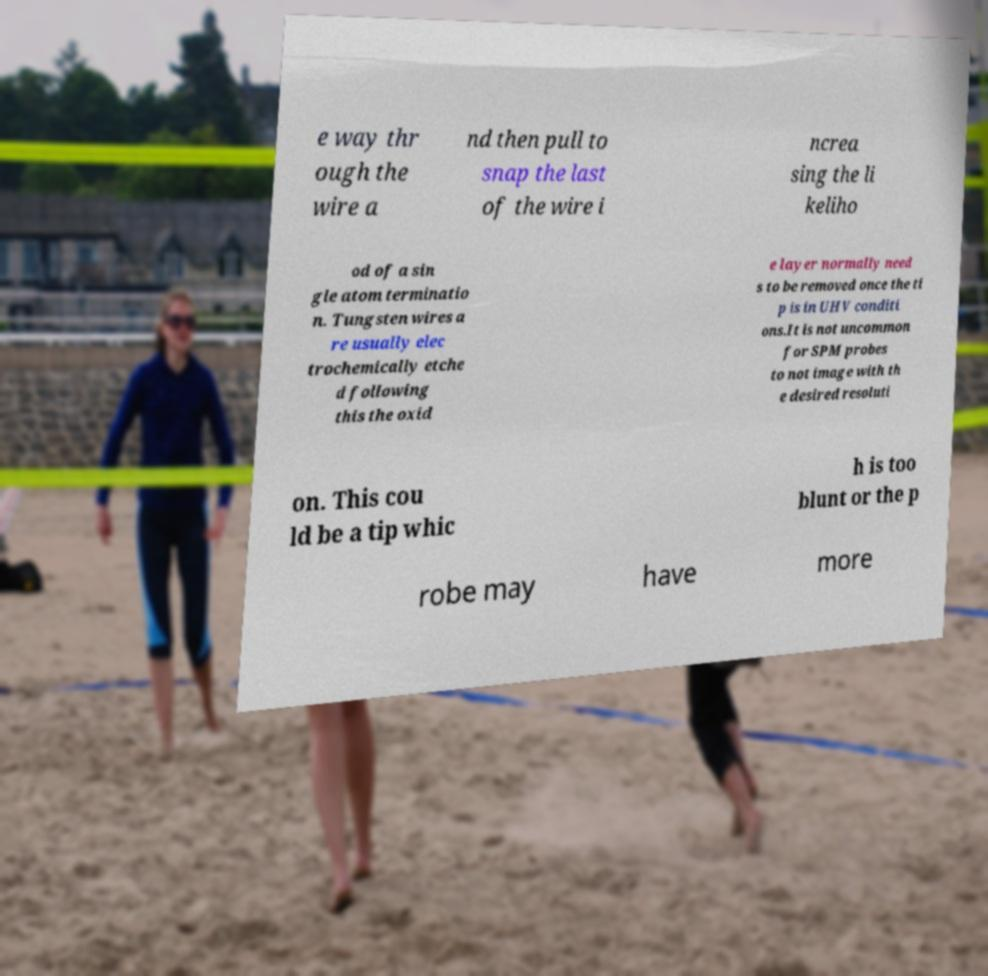Could you extract and type out the text from this image? e way thr ough the wire a nd then pull to snap the last of the wire i ncrea sing the li keliho od of a sin gle atom terminatio n. Tungsten wires a re usually elec trochemically etche d following this the oxid e layer normally need s to be removed once the ti p is in UHV conditi ons.It is not uncommon for SPM probes to not image with th e desired resoluti on. This cou ld be a tip whic h is too blunt or the p robe may have more 